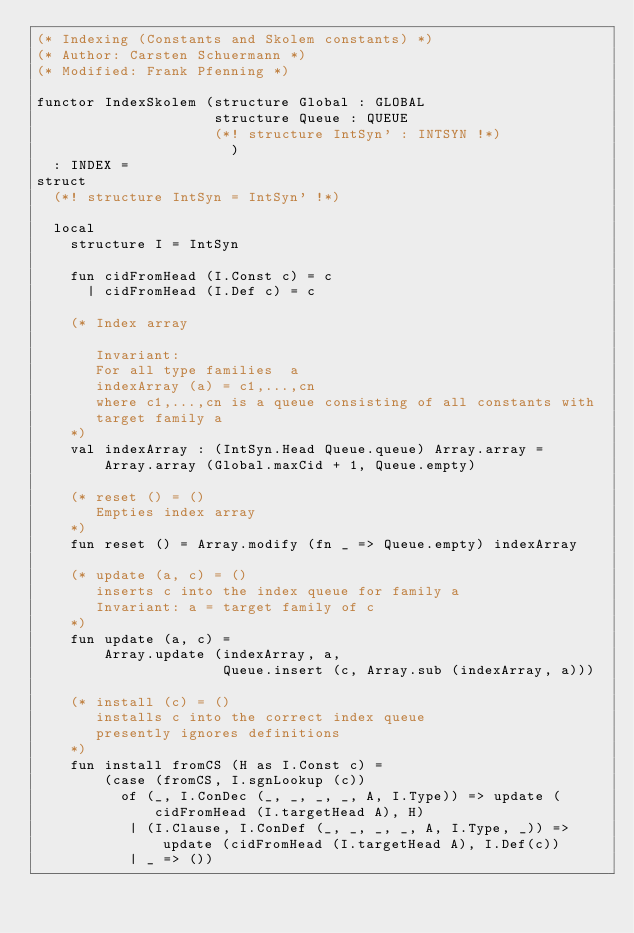<code> <loc_0><loc_0><loc_500><loc_500><_SML_>(* Indexing (Constants and Skolem constants) *)
(* Author: Carsten Schuermann *)
(* Modified: Frank Pfenning *)

functor IndexSkolem (structure Global : GLOBAL
                     structure Queue : QUEUE
                     (*! structure IntSyn' : INTSYN !*)
                       )
  : INDEX =
struct
  (*! structure IntSyn = IntSyn' !*)

  local
    structure I = IntSyn

    fun cidFromHead (I.Const c) = c
      | cidFromHead (I.Def c) = c

    (* Index array

       Invariant:
       For all type families  a
       indexArray (a) = c1,...,cn
       where c1,...,cn is a queue consisting of all constants with
       target family a
    *)
    val indexArray : (IntSyn.Head Queue.queue) Array.array =
        Array.array (Global.maxCid + 1, Queue.empty)

    (* reset () = ()
       Empties index array
    *)
    fun reset () = Array.modify (fn _ => Queue.empty) indexArray

    (* update (a, c) = ()
       inserts c into the index queue for family a
       Invariant: a = target family of c
    *)
    fun update (a, c) =
        Array.update (indexArray, a,
                      Queue.insert (c, Array.sub (indexArray, a)))

    (* install (c) = ()
       installs c into the correct index queue
       presently ignores definitions
    *)
    fun install fromCS (H as I.Const c) =
        (case (fromCS, I.sgnLookup (c))
          of (_, I.ConDec (_, _, _, _, A, I.Type)) => update (cidFromHead (I.targetHead A), H)
           | (I.Clause, I.ConDef (_, _, _, _, A, I.Type, _)) => update (cidFromHead (I.targetHead A), I.Def(c))
           | _ => ())</code> 